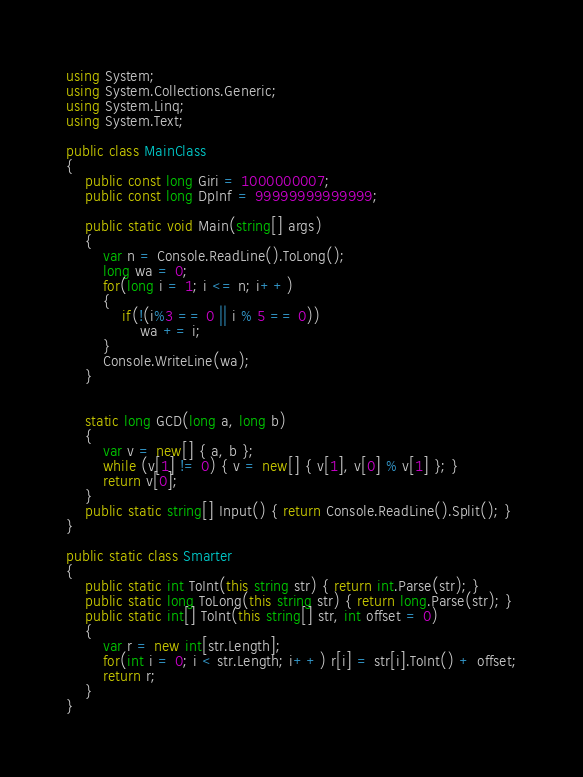Convert code to text. <code><loc_0><loc_0><loc_500><loc_500><_C#_>using System;
using System.Collections.Generic;
using System.Linq;
using System.Text;

public class MainClass
{
	public const long Giri = 1000000007;
	public const long DpInf = 99999999999999;
	
	public static void Main(string[] args)
	{
		var n = Console.ReadLine().ToLong();
		long wa = 0;
		for(long i = 1; i <= n; i++)
		{
			if(!(i%3 == 0 || i % 5 == 0))
				wa += i;
		}
		Console.WriteLine(wa);
	}

	
	static long GCD(long a, long b)
	{
		var v = new[] { a, b };
		while (v[1] != 0) { v = new[] { v[1], v[0] % v[1] }; }
		return v[0];
	}
	public static string[] Input() { return Console.ReadLine().Split(); }
}

public static class Smarter
{
	public static int ToInt(this string str) { return int.Parse(str); }
	public static long ToLong(this string str) { return long.Parse(str); }
	public static int[] ToInt(this string[] str, int offset = 0)
	{
		var r = new int[str.Length];
		for(int i = 0; i < str.Length; i++) r[i] = str[i].ToInt() + offset;
		return r;
	}
}</code> 